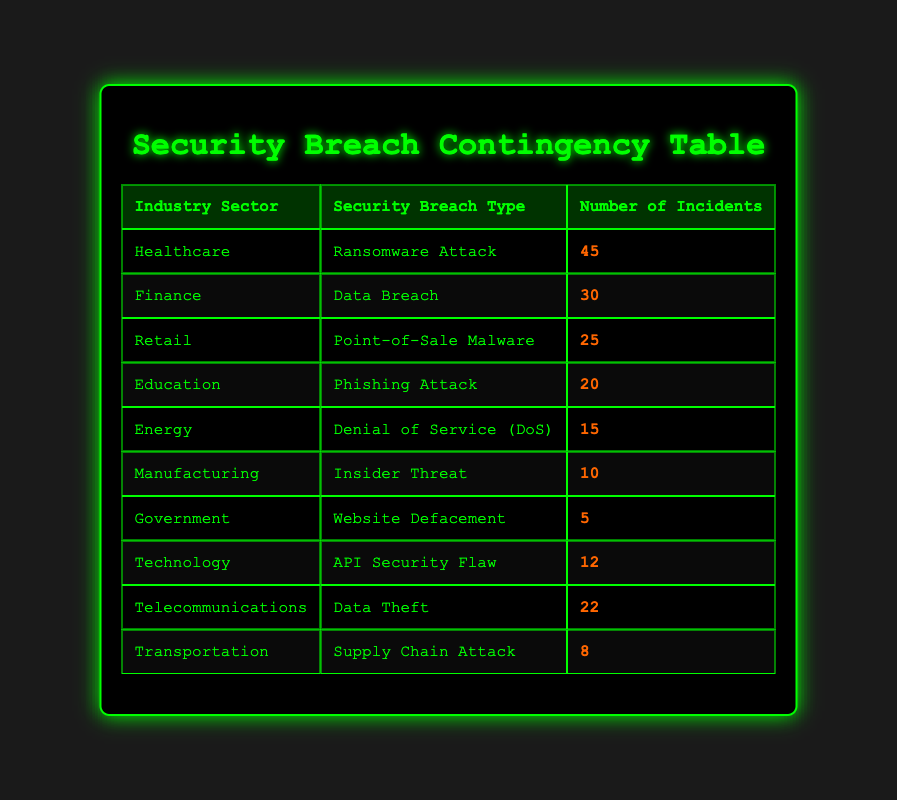What is the highest number of incidents reported in a single industry sector? By reviewing the table, the highest number is 45 incidents reported in the Healthcare sector.
Answer: 45 Which industry sector has experienced a Denial of Service incident? The Energy sector is the only industry that has experienced 15 incidents of Denial of Service.
Answer: Energy How many incidents were reported in the Retail and Technology sectors combined? The Retail sector experienced 25 incidents and the Technology sector had 12 incidents. So, 25 + 12 = 37 incidents in total.
Answer: 37 Is the number of Ransomware Attacks greater than the combined total of Insider Threat incidents and Supply Chain Attack incidents? The Healthcare sector had 45 Ransomware Attacks. The Manufacturing sector reported 10 Insider Threat incidents and the Transportation sector had 8 Supply Chain Attacks. Adding these gives 10 + 8 = 18. Since 45 is greater than 18, the statement is true.
Answer: Yes What is the average number of incidents across all industry sectors? To find the average, first sum the number of incidents: 45 + 30 + 25 + 20 + 15 + 10 + 5 + 12 + 22 + 8 = 192. There are 10 sectors, so the average is 192 / 10 = 19.2.
Answer: 19.2 